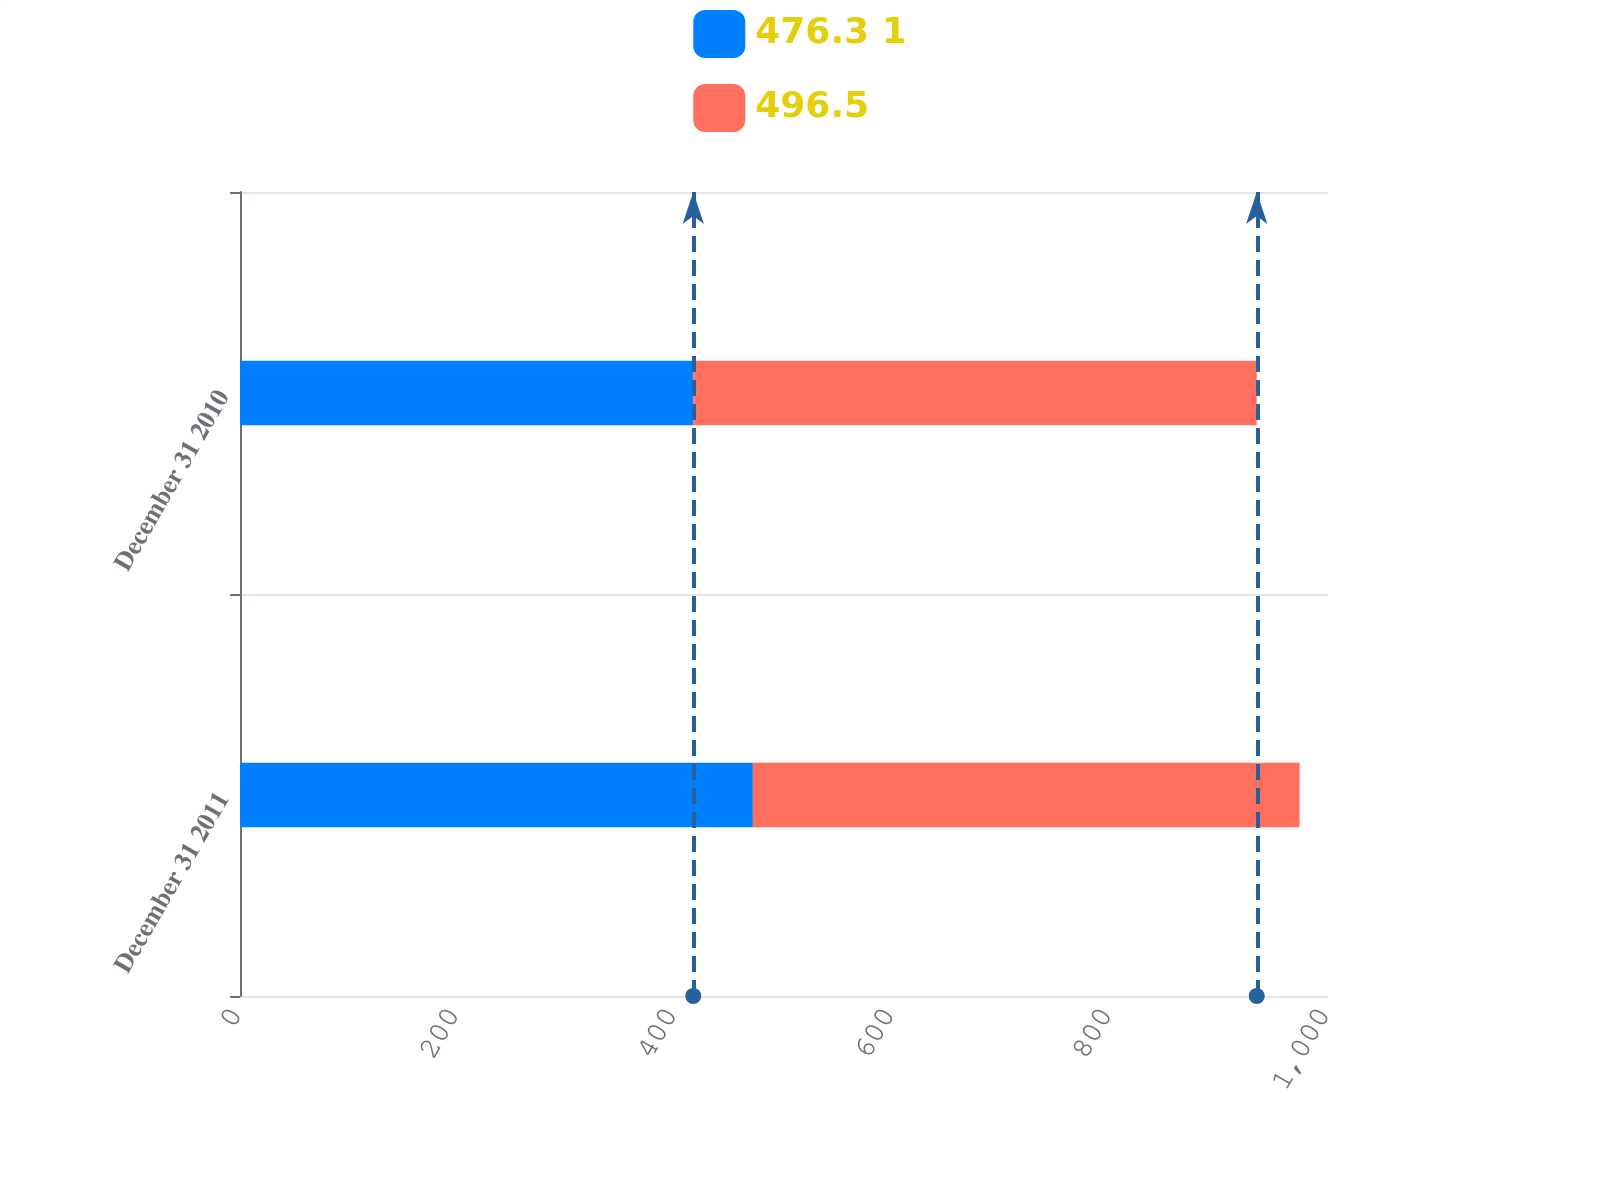<chart> <loc_0><loc_0><loc_500><loc_500><stacked_bar_chart><ecel><fcel>December 31 2011<fcel>December 31 2010<nl><fcel>476.3 1<fcel>471.4<fcel>416.6<nl><fcel>496.5<fcel>502.5<fcel>517.9<nl></chart> 